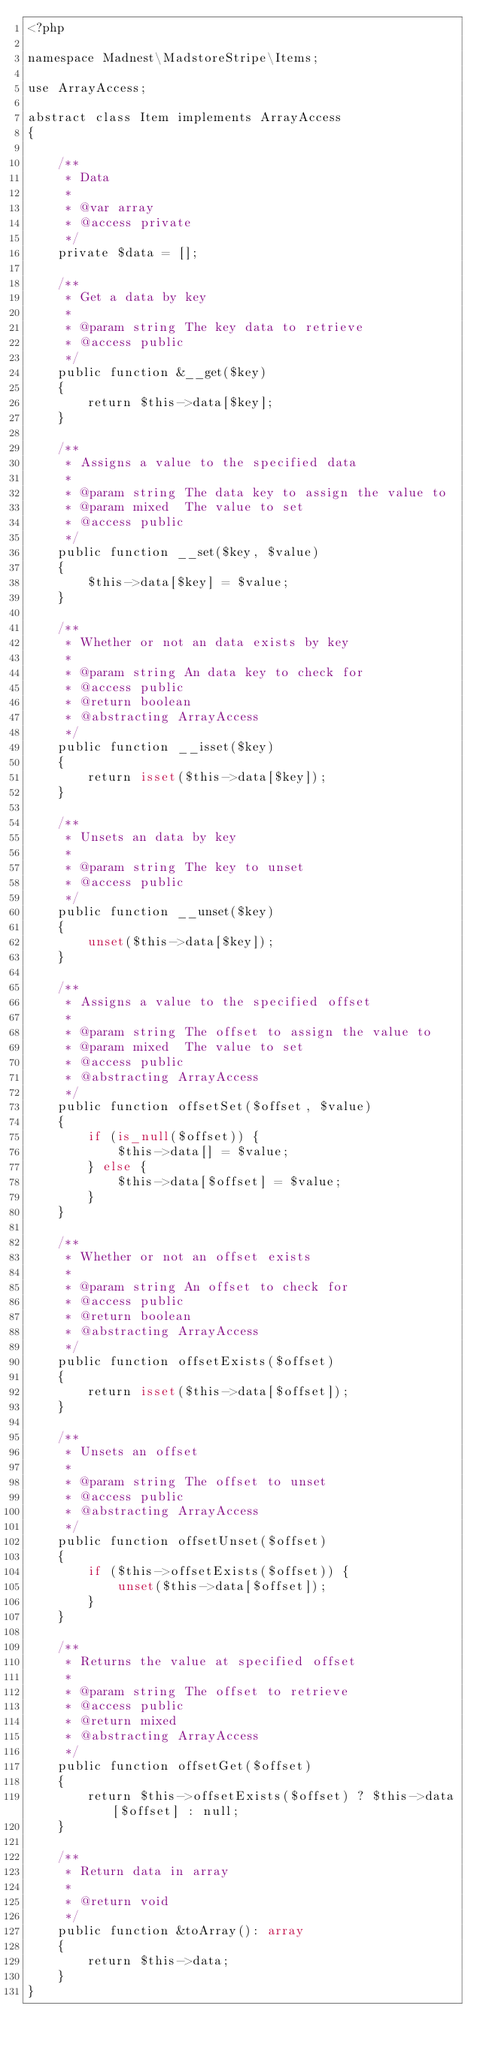<code> <loc_0><loc_0><loc_500><loc_500><_PHP_><?php

namespace Madnest\MadstoreStripe\Items;

use ArrayAccess;

abstract class Item implements ArrayAccess
{

    /**
     * Data
     *
     * @var array
     * @access private
     */
    private $data = [];

    /**
     * Get a data by key
     *
     * @param string The key data to retrieve
     * @access public
     */
    public function &__get($key)
    {
        return $this->data[$key];
    }

    /**
     * Assigns a value to the specified data
     *
     * @param string The data key to assign the value to
     * @param mixed  The value to set
     * @access public
     */
    public function __set($key, $value)
    {
        $this->data[$key] = $value;
    }

    /**
     * Whether or not an data exists by key
     *
     * @param string An data key to check for
     * @access public
     * @return boolean
     * @abstracting ArrayAccess
     */
    public function __isset($key)
    {
        return isset($this->data[$key]);
    }

    /**
     * Unsets an data by key
     *
     * @param string The key to unset
     * @access public
     */
    public function __unset($key)
    {
        unset($this->data[$key]);
    }

    /**
     * Assigns a value to the specified offset
     *
     * @param string The offset to assign the value to
     * @param mixed  The value to set
     * @access public
     * @abstracting ArrayAccess
     */
    public function offsetSet($offset, $value)
    {
        if (is_null($offset)) {
            $this->data[] = $value;
        } else {
            $this->data[$offset] = $value;
        }
    }

    /**
     * Whether or not an offset exists
     *
     * @param string An offset to check for
     * @access public
     * @return boolean
     * @abstracting ArrayAccess
     */
    public function offsetExists($offset)
    {
        return isset($this->data[$offset]);
    }

    /**
     * Unsets an offset
     *
     * @param string The offset to unset
     * @access public
     * @abstracting ArrayAccess
     */
    public function offsetUnset($offset)
    {
        if ($this->offsetExists($offset)) {
            unset($this->data[$offset]);
        }
    }

    /**
     * Returns the value at specified offset
     *
     * @param string The offset to retrieve
     * @access public
     * @return mixed
     * @abstracting ArrayAccess
     */
    public function offsetGet($offset)
    {
        return $this->offsetExists($offset) ? $this->data[$offset] : null;
    }

    /**
     * Return data in array
     *
     * @return void
     */
    public function &toArray(): array
    {
        return $this->data;
    }
}
</code> 